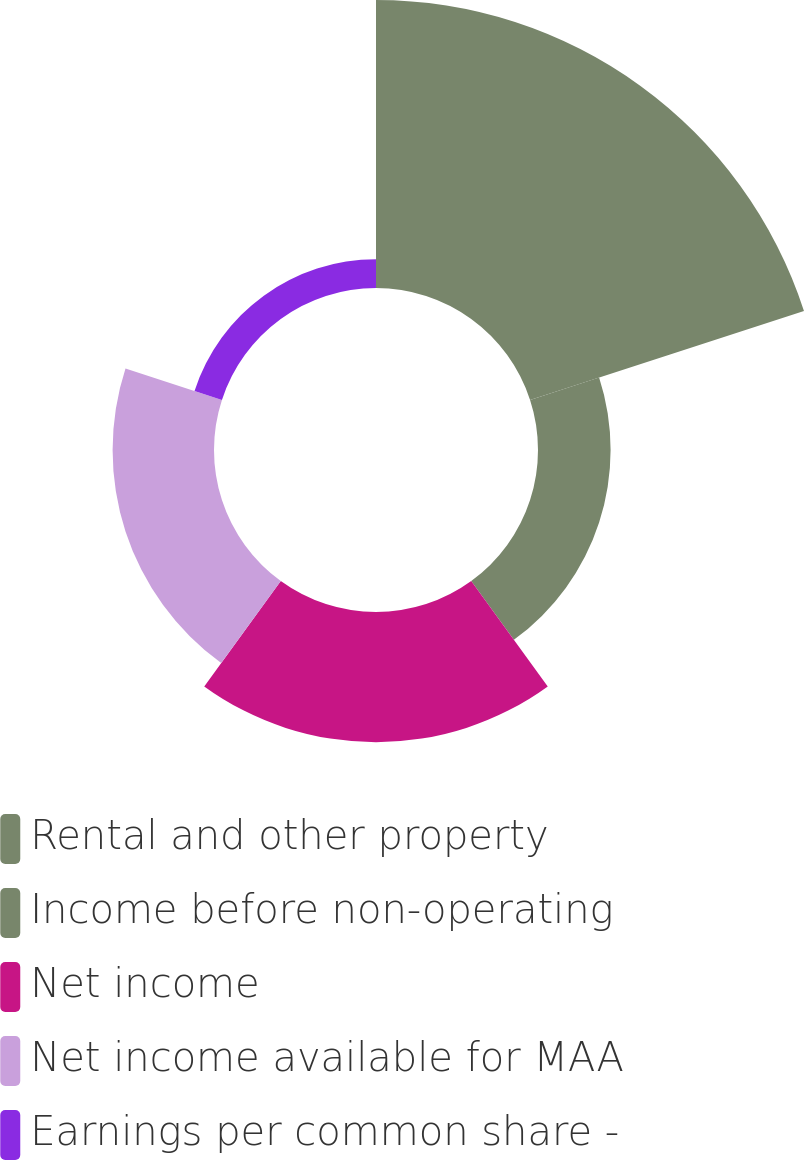Convert chart to OTSL. <chart><loc_0><loc_0><loc_500><loc_500><pie_chart><fcel>Rental and other property<fcel>Income before non-operating<fcel>Net income<fcel>Net income available for MAA<fcel>Earnings per common share -<nl><fcel>46.38%<fcel>11.69%<fcel>20.97%<fcel>16.33%<fcel>4.64%<nl></chart> 